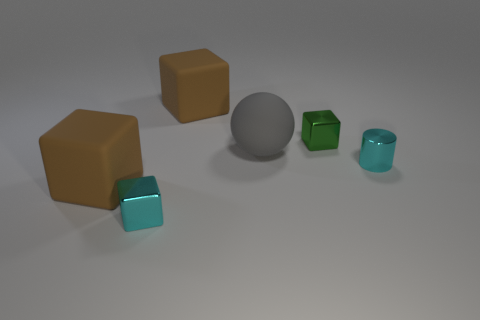Subtract all red cubes. Subtract all brown cylinders. How many cubes are left? 4 Add 2 small brown blocks. How many objects exist? 8 Subtract all balls. How many objects are left? 5 Add 3 large brown objects. How many large brown objects exist? 5 Subtract 0 red spheres. How many objects are left? 6 Subtract all small blue blocks. Subtract all green objects. How many objects are left? 5 Add 4 cyan cylinders. How many cyan cylinders are left? 5 